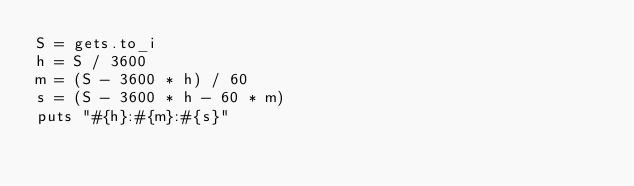Convert code to text. <code><loc_0><loc_0><loc_500><loc_500><_Ruby_>S = gets.to_i
h = S / 3600
m = (S - 3600 * h) / 60
s = (S - 3600 * h - 60 * m)
puts "#{h}:#{m}:#{s}"

</code> 